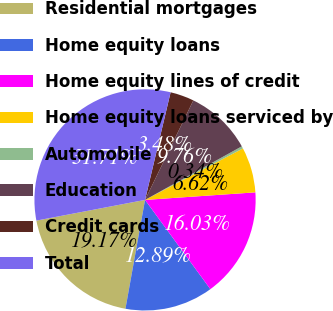<chart> <loc_0><loc_0><loc_500><loc_500><pie_chart><fcel>Residential mortgages<fcel>Home equity loans<fcel>Home equity lines of credit<fcel>Home equity loans serviced by<fcel>Automobile<fcel>Education<fcel>Credit cards<fcel>Total<nl><fcel>19.17%<fcel>12.89%<fcel>16.03%<fcel>6.62%<fcel>0.34%<fcel>9.76%<fcel>3.48%<fcel>31.71%<nl></chart> 